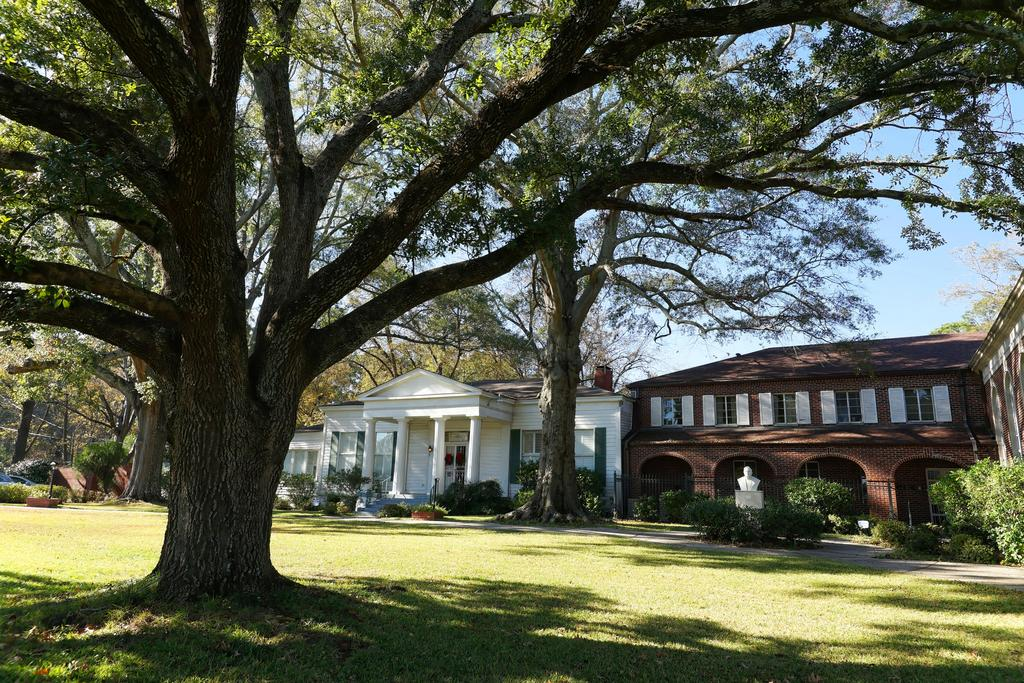What is located on the left side of the image? There is a tree on the left side of the image. What type of vegetation is present on the ground? There is grass on the ground. What can be seen in the background of the image? Buildings, windows, doors, a statue on a platform, trees, and the sky are visible in the background of the image. How many kittens are playing in the rhythm of the statue's movement in the image? There are no kittens or any indication of rhythm present in the image. The statue is stationary on a platform, and the image does not depict any kittens or movement related to rhythm. 